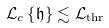Convert formula to latex. <formula><loc_0><loc_0><loc_500><loc_500>\mathcal { L } _ { c } \left \{ \mathfrak { h } \right \} \lesssim \mathcal { L } _ { \text {thr} }</formula> 